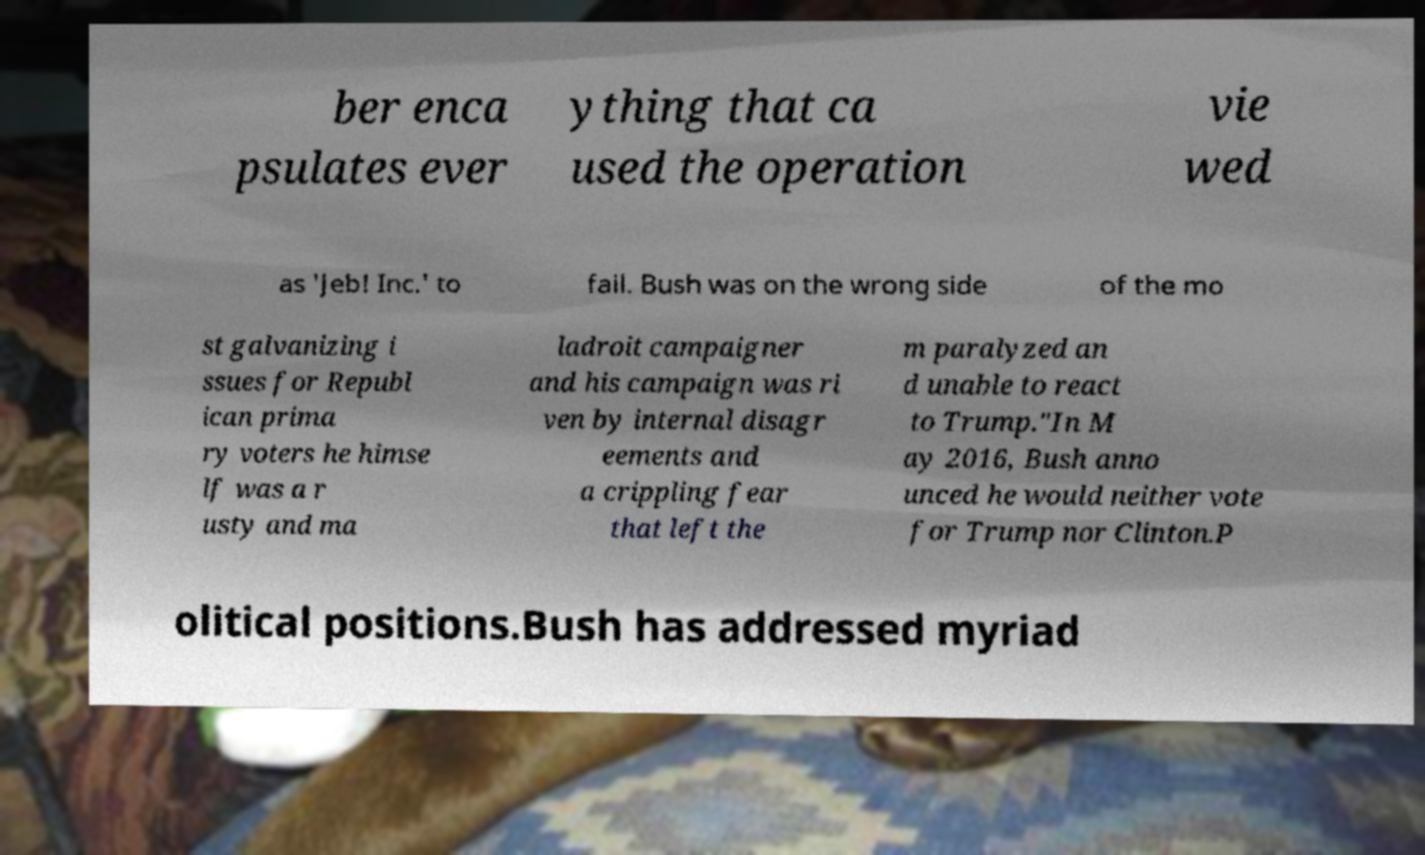There's text embedded in this image that I need extracted. Can you transcribe it verbatim? ber enca psulates ever ything that ca used the operation vie wed as 'Jeb! Inc.' to fail. Bush was on the wrong side of the mo st galvanizing i ssues for Republ ican prima ry voters he himse lf was a r usty and ma ladroit campaigner and his campaign was ri ven by internal disagr eements and a crippling fear that left the m paralyzed an d unable to react to Trump."In M ay 2016, Bush anno unced he would neither vote for Trump nor Clinton.P olitical positions.Bush has addressed myriad 